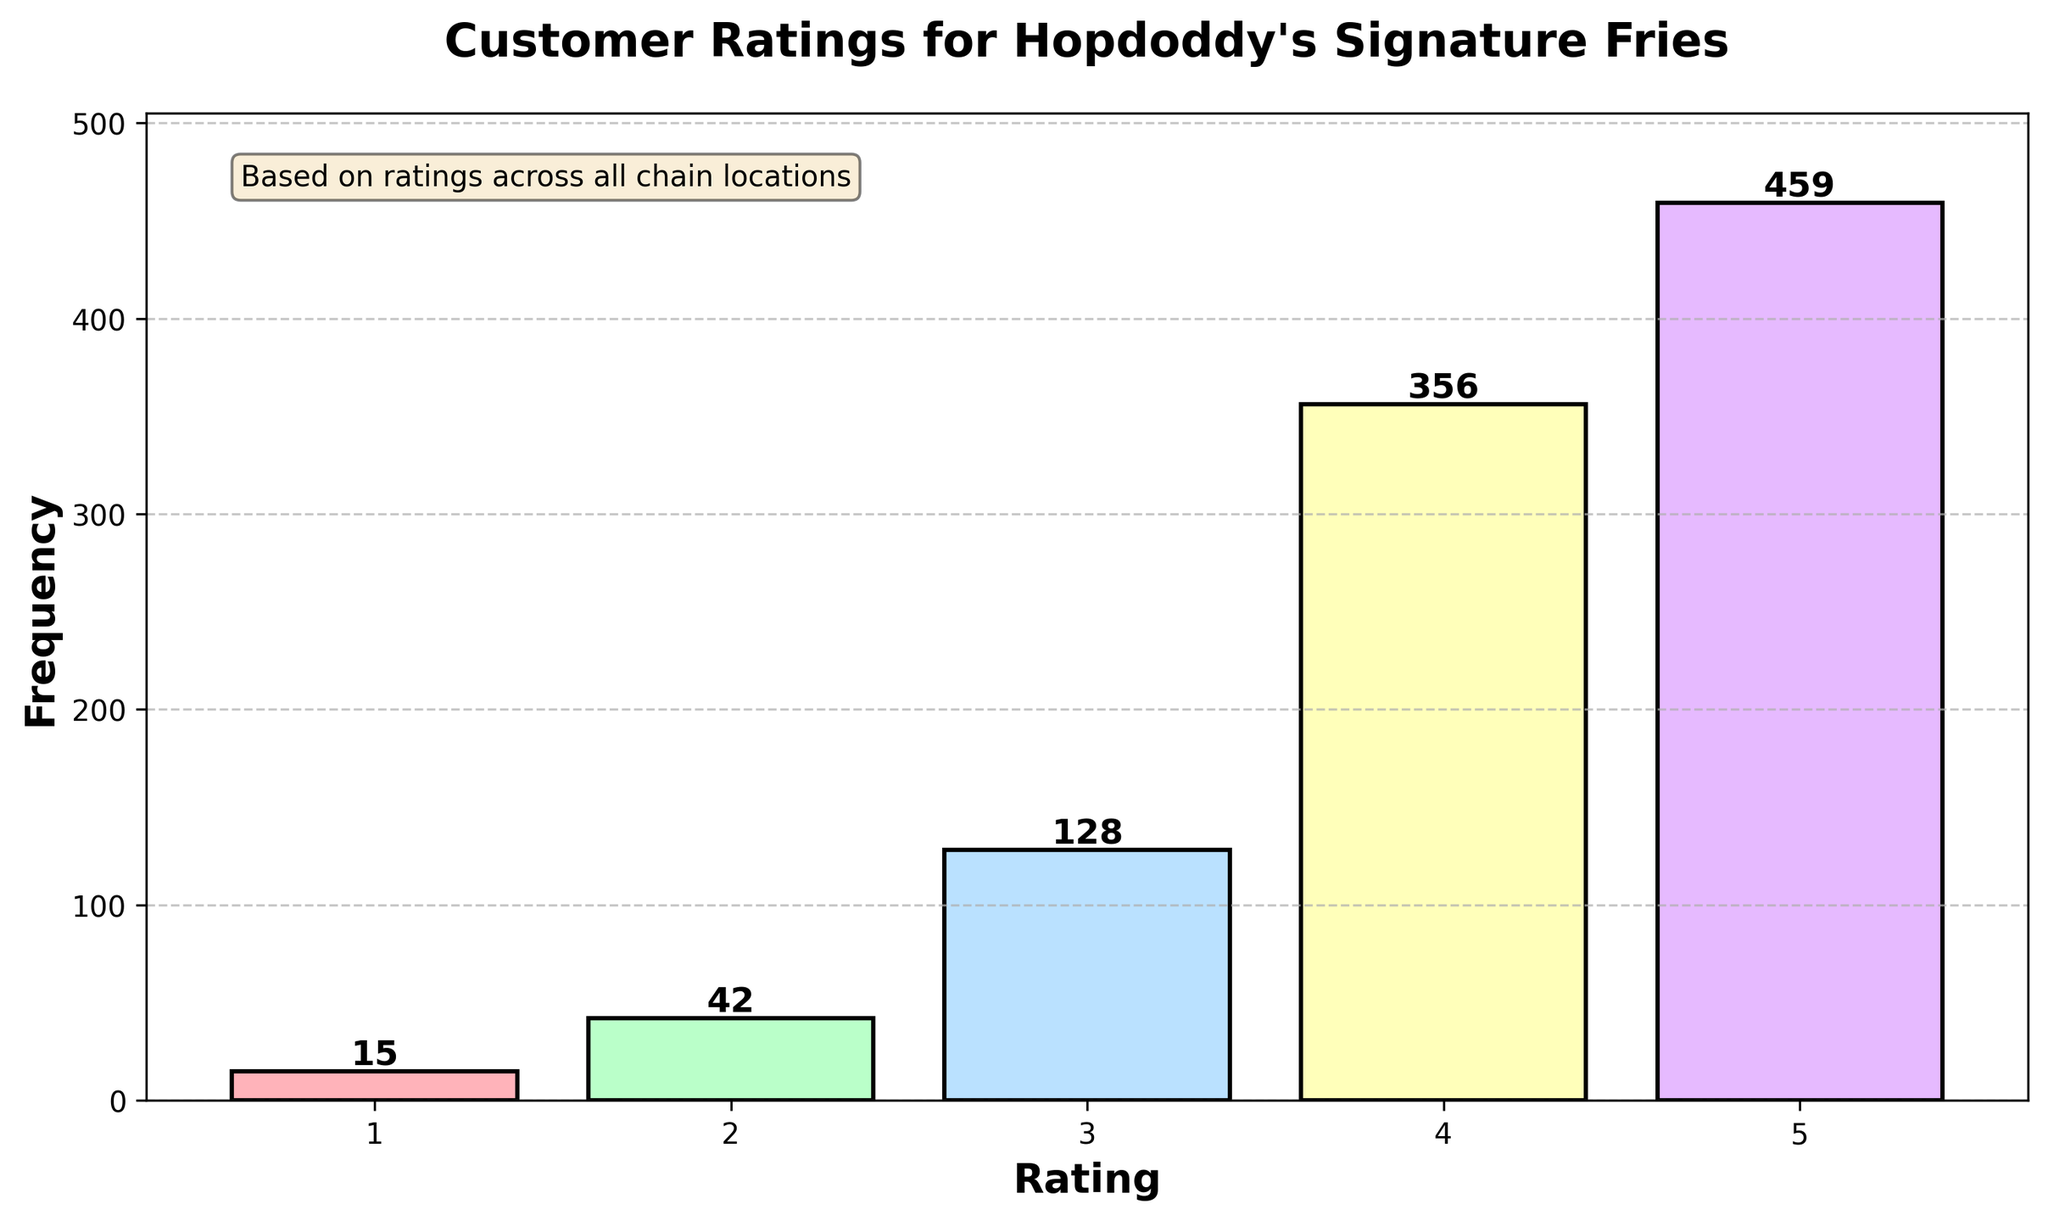What is the title of the figure? The title is usually located at the top of the figure. It helps understand what the graph is about. In this case, it reads "Customer Ratings for Hopdoddy's Signature Fries."
Answer: Customer Ratings for Hopdoddy's Signature Fries How many different rating categories are there? By looking at the x-axis, it shows ratings from 1 to 5, indicating there are 5 different rating categories.
Answer: 5 Which rating has the highest frequency? The height of the bars represents the frequency. The tallest bar corresponds to the 5-star rating.
Answer: 5-star What is the frequency of the 3-star rating? The frequency of each rating is displayed on top of each bar. For the 3-star rating, it shows the number 128.
Answer: 128 Which rating received the least frequency? The shortest bar corresponds to the 1-star rating, which is the lowest among the five.
Answer: 1-star What is the combined frequency of 1-star and 2-star ratings? Adding the frequency of 1-star (15) and 2-star (42) ratings yields the combined frequency: 15 + 42 = 57.
Answer: 57 By how much does the 5-star rating frequency exceed the 4-star rating frequency? Subtracting the frequency of the 4-star rating (356) from the 5-star rating (459) gives: 459 - 356 = 103.
Answer: 103 What percentage of the total ratings does the 4-star rating constitute? First, calculate the total number of ratings by summing all frequencies: 15 + 42 + 128 + 356 + 459 = 1000. Then divide the 4-star frequency by the total and multiply by 100: (356 / 1000) * 100 = 35.6%.
Answer: 35.6% How does the frequency of the 2-star rating compare to the frequency of the 3-star rating? The frequency of the 3-star rating (128) is higher than that of the 2-star rating (42).
Answer: 3-star is higher What is the average frequency of ratings from 1-star to 5-star? Adding all frequencies gives 1000. Dividing by the number of categories (5) yields: 1000 / 5 = 200.
Answer: 200 